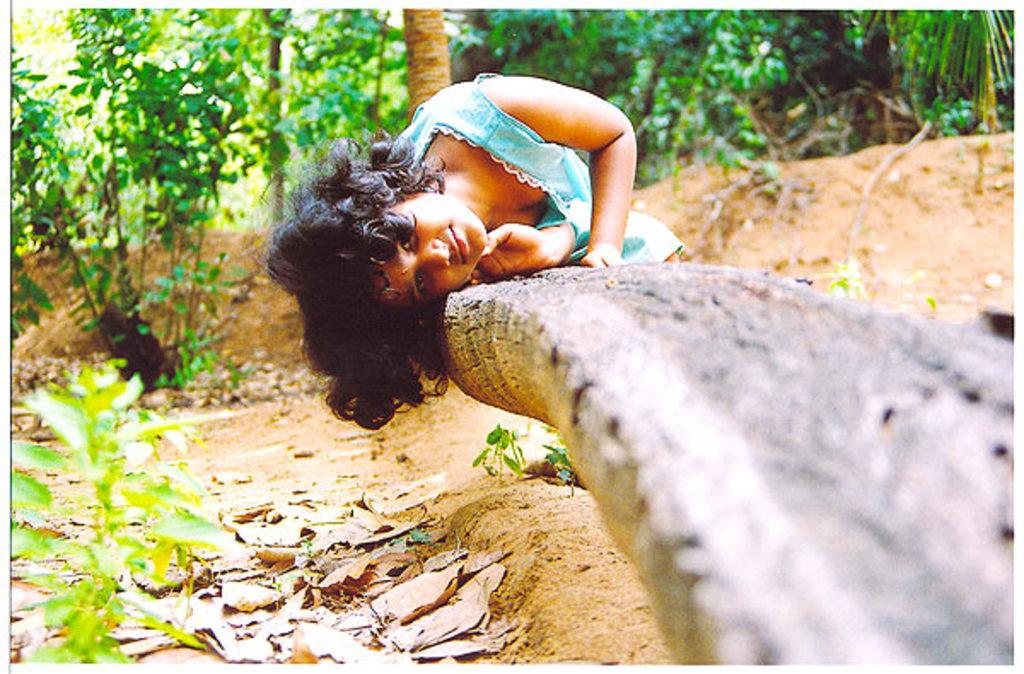What is the girl doing in the image? The girl is lying on a wooden trunk in the image. What can be seen on the left side of the image? There is a plant on the left side of the image. What is visible in the background of the image? There are trees in the background of the image. What type of magic is the girl performing in the image? There is no indication of magic or any magical activity in the image. 